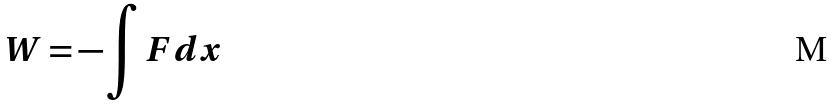Convert formula to latex. <formula><loc_0><loc_0><loc_500><loc_500>W = - \int F d x</formula> 